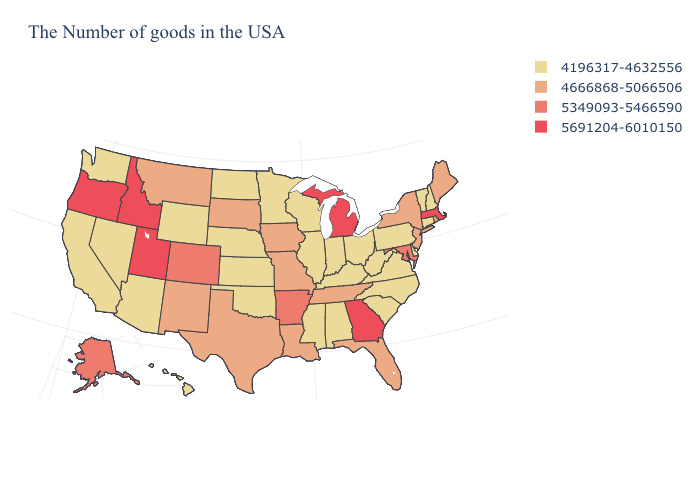What is the highest value in states that border Wisconsin?
Concise answer only. 5691204-6010150. How many symbols are there in the legend?
Write a very short answer. 4. What is the highest value in states that border South Carolina?
Be succinct. 5691204-6010150. Name the states that have a value in the range 4666868-5066506?
Short answer required. Maine, Rhode Island, New York, New Jersey, Florida, Tennessee, Louisiana, Missouri, Iowa, Texas, South Dakota, New Mexico, Montana. What is the highest value in the MidWest ?
Be succinct. 5691204-6010150. Does the map have missing data?
Give a very brief answer. No. Name the states that have a value in the range 4666868-5066506?
Be succinct. Maine, Rhode Island, New York, New Jersey, Florida, Tennessee, Louisiana, Missouri, Iowa, Texas, South Dakota, New Mexico, Montana. How many symbols are there in the legend?
Answer briefly. 4. Which states have the highest value in the USA?
Short answer required. Massachusetts, Georgia, Michigan, Utah, Idaho, Oregon. What is the value of Colorado?
Keep it brief. 5349093-5466590. What is the highest value in states that border Virginia?
Write a very short answer. 5349093-5466590. Which states have the highest value in the USA?
Write a very short answer. Massachusetts, Georgia, Michigan, Utah, Idaho, Oregon. What is the value of California?
Answer briefly. 4196317-4632556. What is the value of New Hampshire?
Be succinct. 4196317-4632556. 